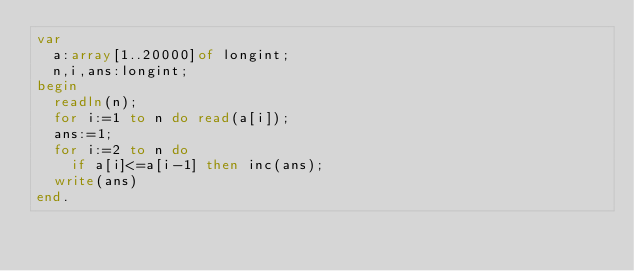Convert code to text. <code><loc_0><loc_0><loc_500><loc_500><_Pascal_>var
  a:array[1..20000]of longint;
  n,i,ans:longint;
begin
  readln(n);
  for i:=1 to n do read(a[i]);
  ans:=1;
  for i:=2 to n do
    if a[i]<=a[i-1] then inc(ans);
  write(ans)
end.</code> 